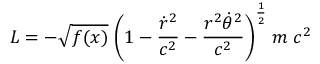Convert formula to latex. <formula><loc_0><loc_0><loc_500><loc_500>L = - \sqrt { f ( x ) } \, \left ( 1 - { \frac { \dot { r } ^ { 2 } } { c ^ { 2 } } } - { \frac { r ^ { 2 } \dot { \theta } ^ { 2 } } { c ^ { 2 } } } \right ) ^ { \frac { 1 } { 2 } } \, m \, c ^ { 2 }</formula> 